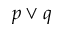<formula> <loc_0><loc_0><loc_500><loc_500>p \vee q</formula> 